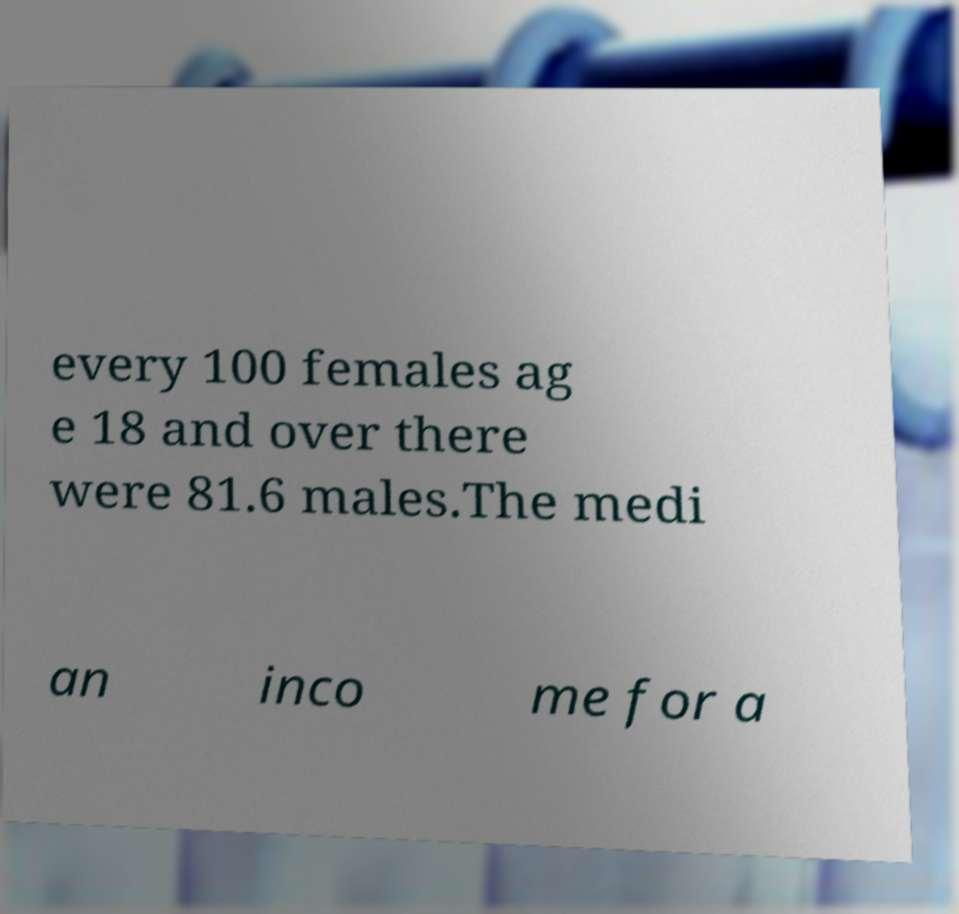I need the written content from this picture converted into text. Can you do that? every 100 females ag e 18 and over there were 81.6 males.The medi an inco me for a 